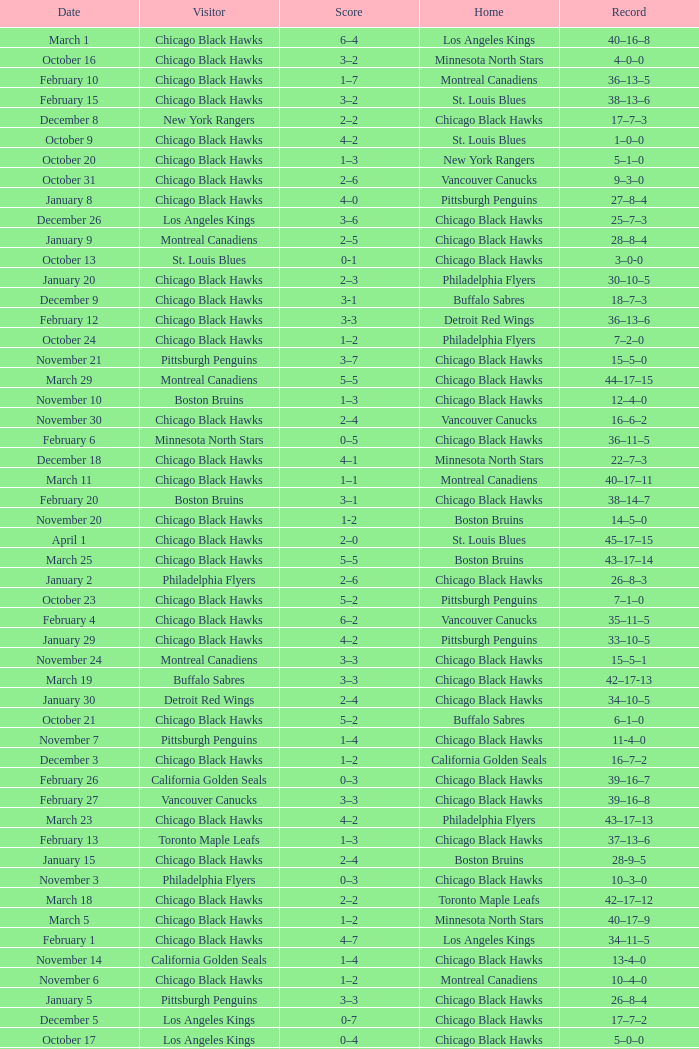What is the Record from February 10? 36–13–5. 